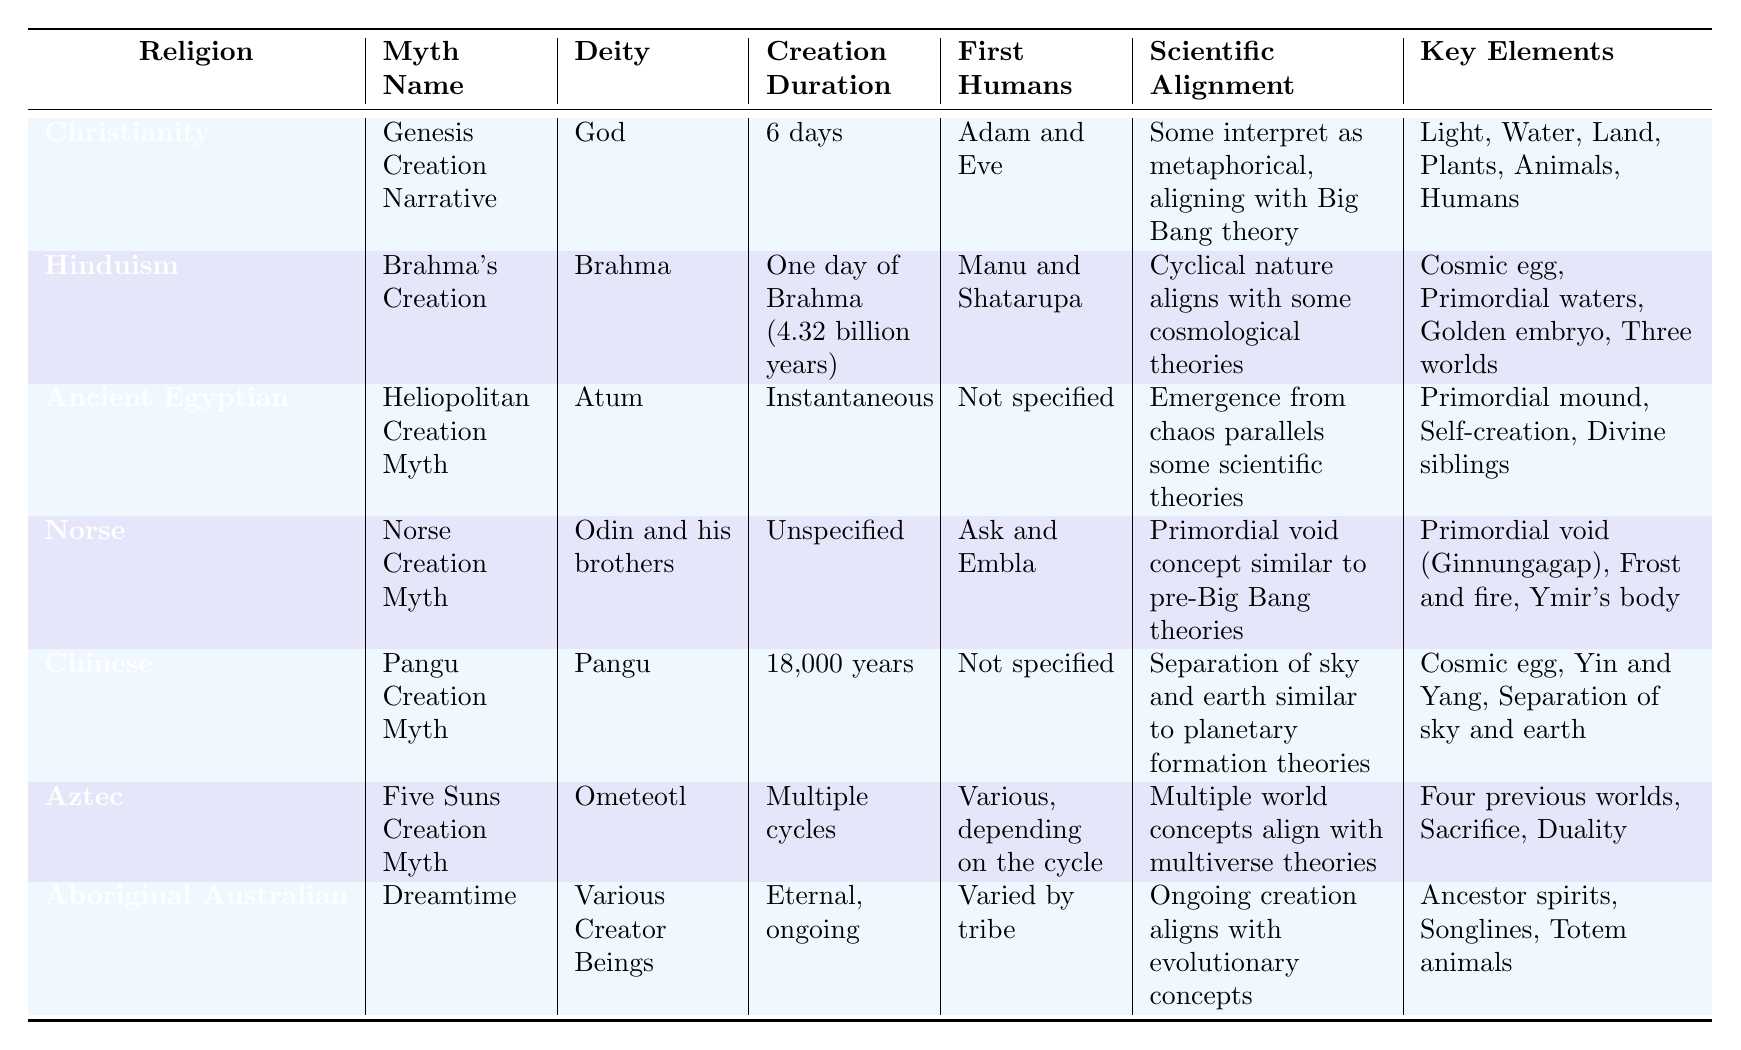What is the creation duration of the Brahma's Creation myth? The table lists "One day of Brahma (4.32 billion years)" under the "Creation Duration" column for Hinduism's myth.
Answer: One day of Brahma (4.32 billion years) Which religion has the first humans named Adam and Eve? Looking at the "First Humans" column, it shows that Christianity has Adam and Eve listed as the first humans.
Answer: Christianity How many religions mention a deity associated with creation? Counting the rows in the table, each of the seven religions mentions a deity in the "Deity" column.
Answer: 7 Do all creation myths specify the first humans created? By examining the "First Humans" column, it can be seen that some entries state "Not specified," indicating not all myths mention first humans.
Answer: No Which myth describes an instantaneous creation? The "Creation Duration" column for the Ancient Egyptian myth states it is "Instantaneous," making that the answer.
Answer: Heliopolitan Creation Myth What is the key element mentioned in the Pangu Creation Myth? The "Key Elements" for the Chinese myth include "Cosmic egg, Yin and Yang, Separation of sky and earth," at least one of which can answer the question.
Answer: Cosmic egg Which creation myth aligns with the Big Bang theory? Christianity's myth in the "Scientific Alignment" column states it is interpreted as metaphorical, aligning with the Big Bang theory.
Answer: Genesis Creation Narrative Identify the two religions that involve the concept of cyclical creation. Hinduism is associated with a cyclical nature in its scientific alignment, while the Aztec myth has multiple cycles indicated in its creation duration.
Answer: Hinduism and Aztec What is the common theme among the myths related to scientific alignment? The table indicates that many myths express alignment with scientific theories, such as cosmological theories and evolutionary concepts, reflecting a common theme of explaining creation through various lenses.
Answer: Alignment with scientific theories Which religion's creation myth involves a Primordial void? The table specifies that the Norse creation myth involves a "Primordial void" as key in its elements.
Answer: Norse Creation Myth 